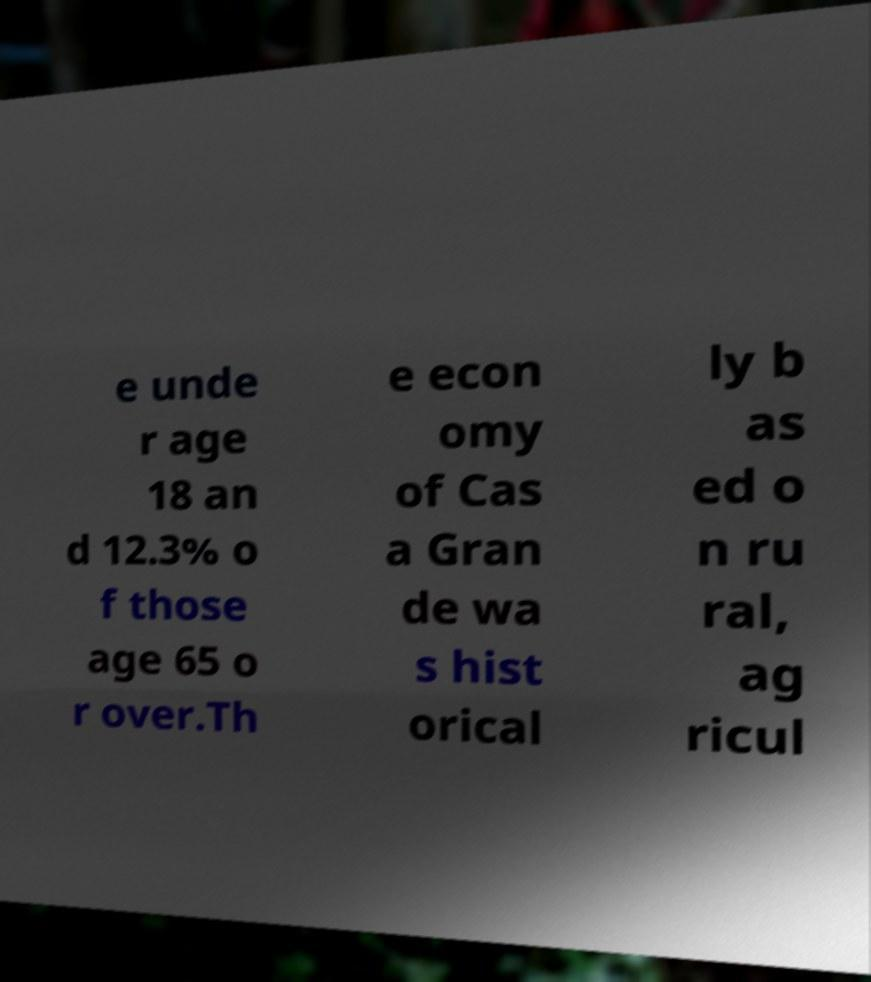There's text embedded in this image that I need extracted. Can you transcribe it verbatim? e unde r age 18 an d 12.3% o f those age 65 o r over.Th e econ omy of Cas a Gran de wa s hist orical ly b as ed o n ru ral, ag ricul 